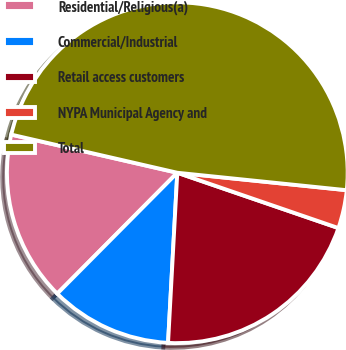Convert chart to OTSL. <chart><loc_0><loc_0><loc_500><loc_500><pie_chart><fcel>Residential/Religious(a)<fcel>Commercial/Industrial<fcel>Retail access customers<fcel>NYPA Municipal Agency and<fcel>Total<nl><fcel>16.15%<fcel>11.58%<fcel>20.6%<fcel>3.63%<fcel>48.04%<nl></chart> 